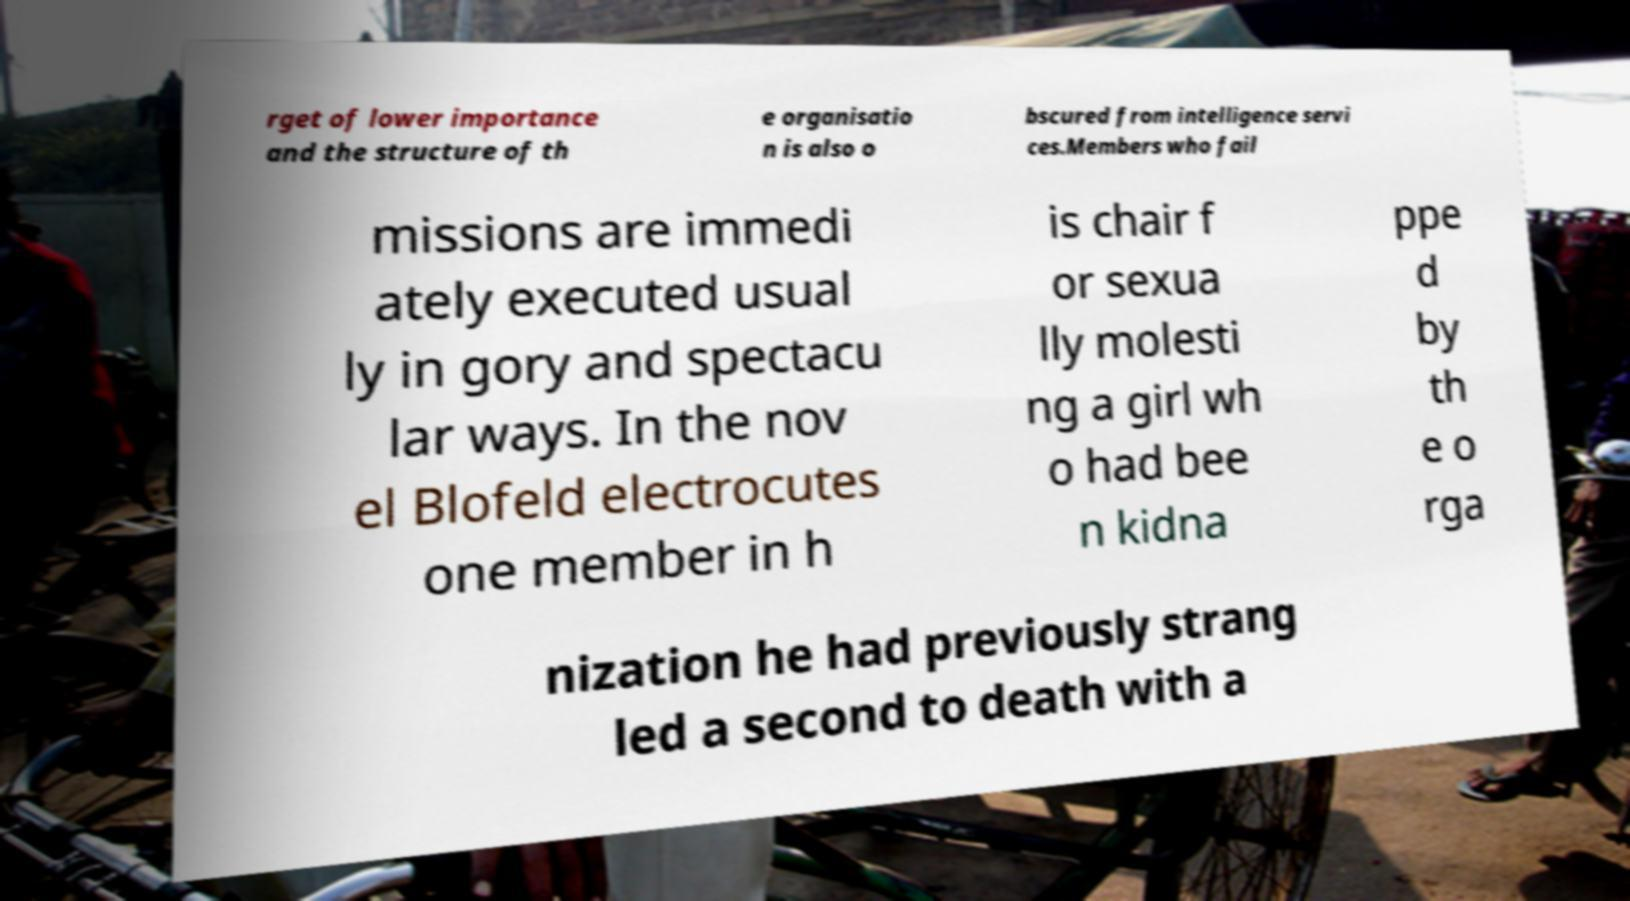Could you extract and type out the text from this image? rget of lower importance and the structure of th e organisatio n is also o bscured from intelligence servi ces.Members who fail missions are immedi ately executed usual ly in gory and spectacu lar ways. In the nov el Blofeld electrocutes one member in h is chair f or sexua lly molesti ng a girl wh o had bee n kidna ppe d by th e o rga nization he had previously strang led a second to death with a 